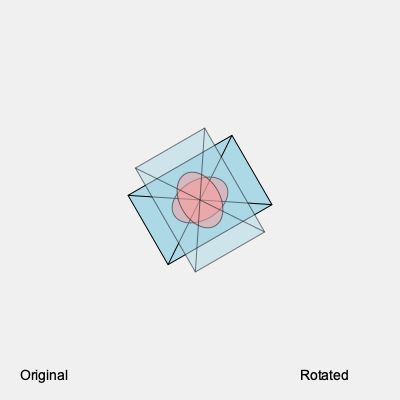As an innovative entrepreneur seeking funding, you've designed a unique product prototype. The image shows two views of your 3D model: the original and a rotated version. By how many degrees and in which direction has the model been rotated? To determine the rotation of the 3D model, we need to follow these steps:

1. Observe the original position of the model (solid lines).
2. Compare it to the rotated position (faded lines).
3. Identify the direction of rotation:
   - The model has moved clockwise from its original position.
4. Calculate the angle of rotation:
   - The original model is at -30 degrees (30 degrees counterclockwise from horizontal).
   - The rotated model is at 60 degrees clockwise from horizontal.
5. Calculate the total rotation:
   - Total rotation = Original position + Clockwise rotation
   - Total rotation = 30° + 60° = 90°

Therefore, the model has been rotated 90 degrees clockwise from its original position.
Answer: 90° clockwise 